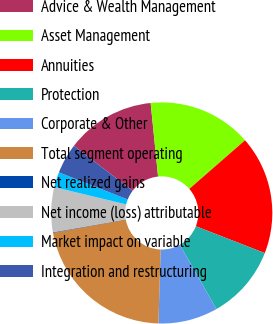Convert chart to OTSL. <chart><loc_0><loc_0><loc_500><loc_500><pie_chart><fcel>Advice & Wealth Management<fcel>Asset Management<fcel>Annuities<fcel>Protection<fcel>Corporate & Other<fcel>Total segment operating<fcel>Net realized gains<fcel>Net income (loss) attributable<fcel>Market impact on variable<fcel>Integration and restructuring<nl><fcel>13.02%<fcel>15.18%<fcel>17.33%<fcel>10.86%<fcel>8.71%<fcel>21.65%<fcel>0.08%<fcel>6.55%<fcel>2.23%<fcel>4.39%<nl></chart> 